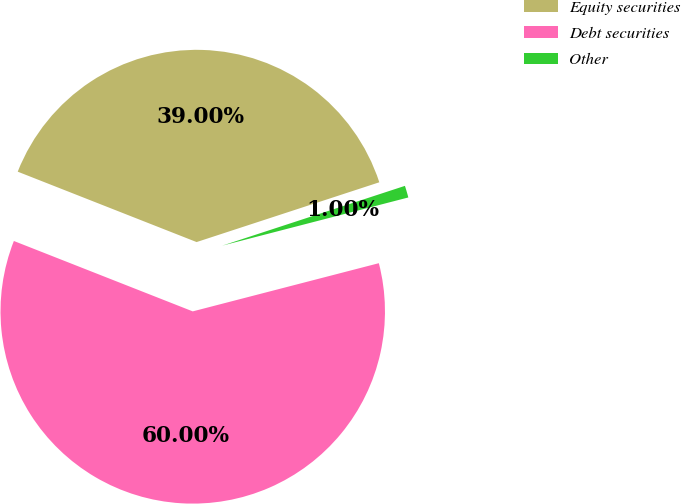Convert chart to OTSL. <chart><loc_0><loc_0><loc_500><loc_500><pie_chart><fcel>Equity securities<fcel>Debt securities<fcel>Other<nl><fcel>39.0%<fcel>60.0%<fcel>1.0%<nl></chart> 